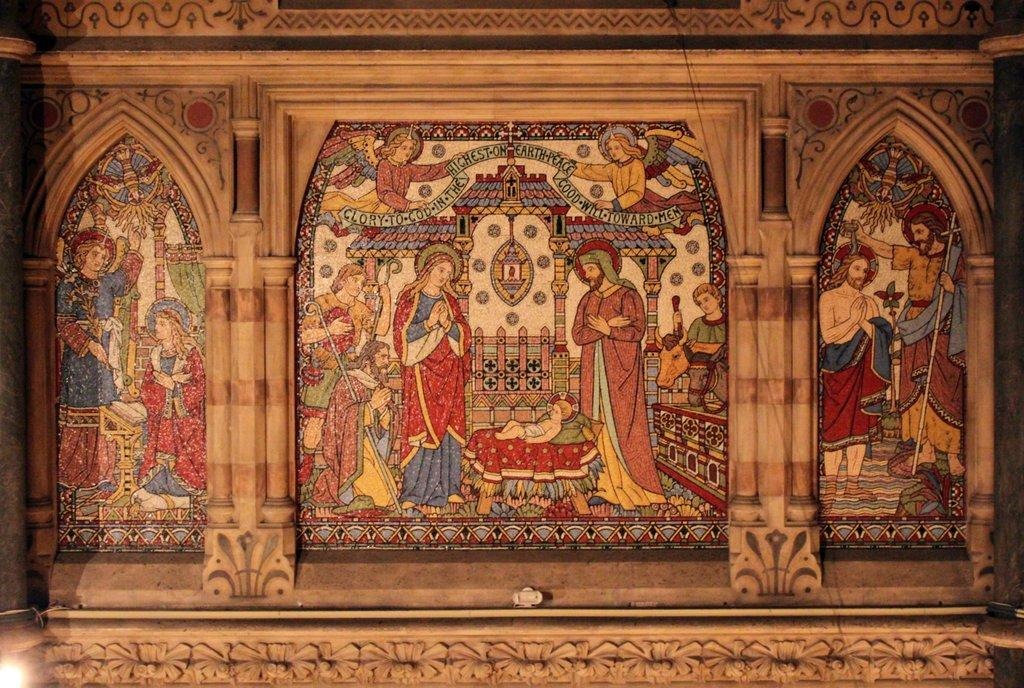What is the main subject of the image? There is a painting in the image. Where is the painting located? The painting is on a wall. What is the content of the painting? The painting depicts people standing around a baby. What can be seen on the wall besides the painting? The wall has carvings on it. What is the baby's idea about the arm in the image? There is no baby's idea or arm present in the image, as it only features a painting of people standing around a baby. 